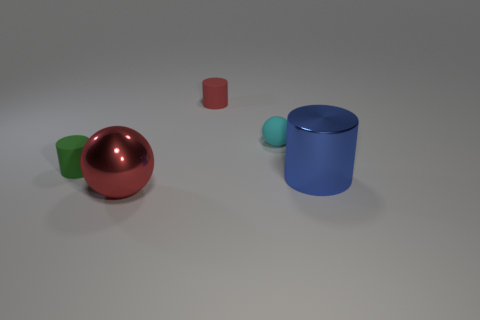There is a cyan thing that is the same size as the green rubber thing; what material is it?
Your answer should be compact. Rubber. Is the big red ball made of the same material as the red cylinder?
Your response must be concise. No. What number of red things have the same material as the red ball?
Provide a succinct answer. 0. How many objects are tiny matte things on the left side of the large sphere or small rubber cylinders that are to the left of the red metal object?
Keep it short and to the point. 1. Is the number of large things that are in front of the large blue metallic cylinder greater than the number of large shiny objects on the left side of the small green thing?
Give a very brief answer. Yes. What color is the big object in front of the blue object?
Provide a short and direct response. Red. Are there any other big cyan things that have the same shape as the cyan matte thing?
Provide a short and direct response. No. What number of blue objects are either big spheres or tiny matte things?
Your answer should be compact. 0. Is there a matte thing of the same size as the blue metal cylinder?
Provide a short and direct response. No. How many big cylinders are there?
Provide a short and direct response. 1. 